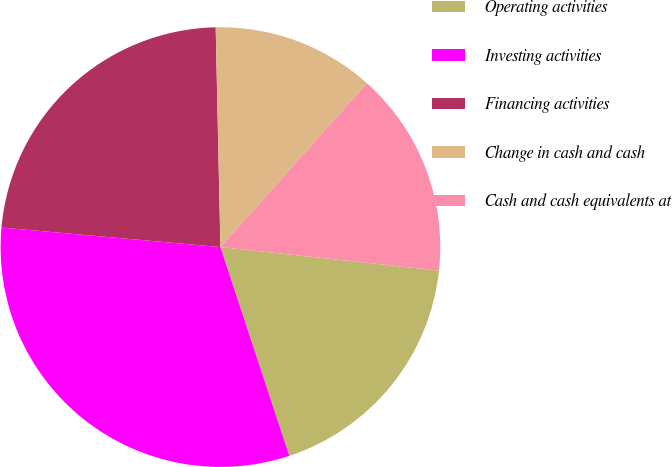Convert chart to OTSL. <chart><loc_0><loc_0><loc_500><loc_500><pie_chart><fcel>Operating activities<fcel>Investing activities<fcel>Financing activities<fcel>Change in cash and cash<fcel>Cash and cash equivalents at<nl><fcel>18.22%<fcel>31.49%<fcel>23.24%<fcel>11.96%<fcel>15.09%<nl></chart> 